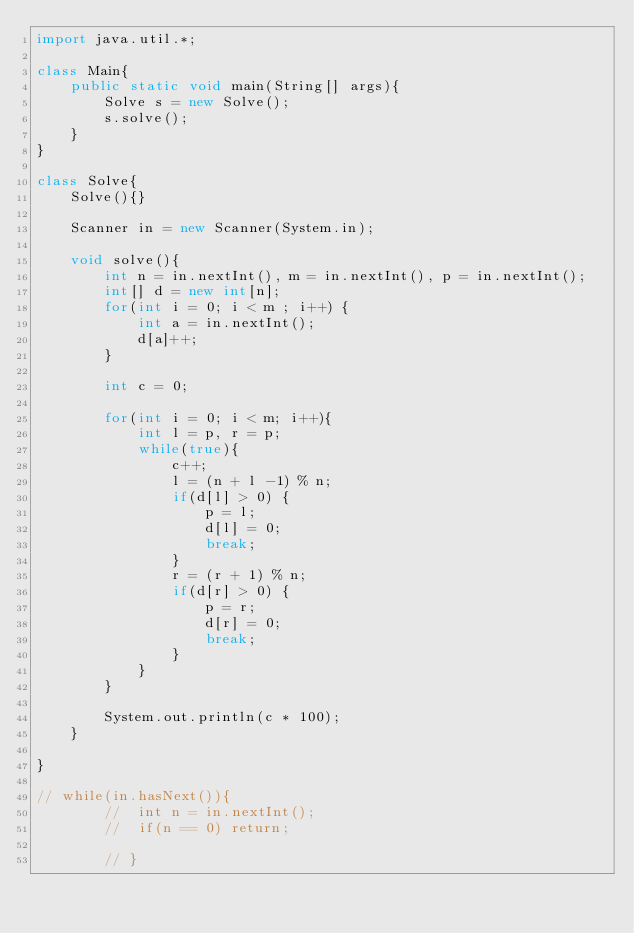<code> <loc_0><loc_0><loc_500><loc_500><_Java_>import java.util.*;

class Main{
	public static void main(String[] args){
		Solve s = new Solve();
		s.solve();
	}	
}

class Solve{
	Solve(){}
	
	Scanner in = new Scanner(System.in);

	void solve(){
		int n = in.nextInt(), m = in.nextInt(), p = in.nextInt();
		int[] d = new int[n];
		for(int i = 0; i < m ; i++) {
			int a = in.nextInt();
			d[a]++;
		}

		int c = 0;

		for(int i = 0; i < m; i++){
			int l = p, r = p;
			while(true){
				c++;
				l = (n + l -1) % n;
				if(d[l] > 0) {
					p = l;
					d[l] = 0;
					break;
				}
				r = (r + 1) % n;
				if(d[r] > 0) {
					p = r;
					d[r] = 0;
					break;
				}
			}
		}

		System.out.println(c * 100);
	}
	
}

// while(in.hasNext()){
		// 	int n = in.nextInt();
		// 	if(n == 0) return;
			
		// }</code> 